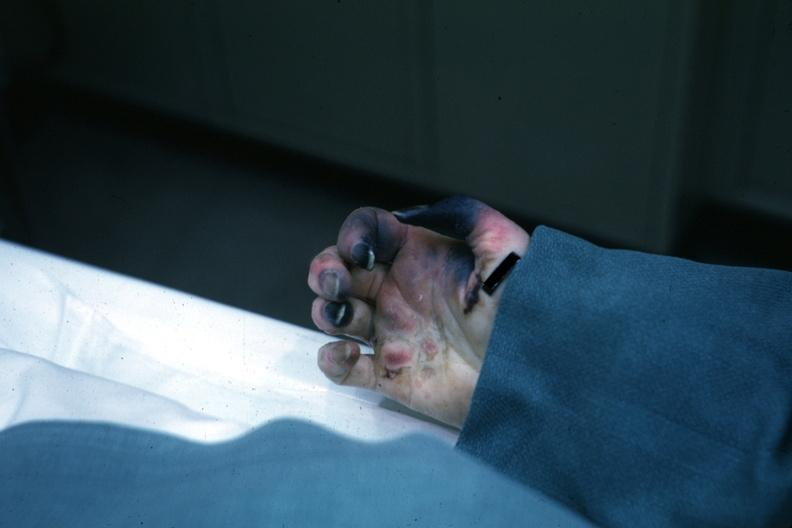what does obvious gangrenous necrosis child with congenital heart disease post op exact cause know?
Answer the question using a single word or phrase. Shock vs emboli 